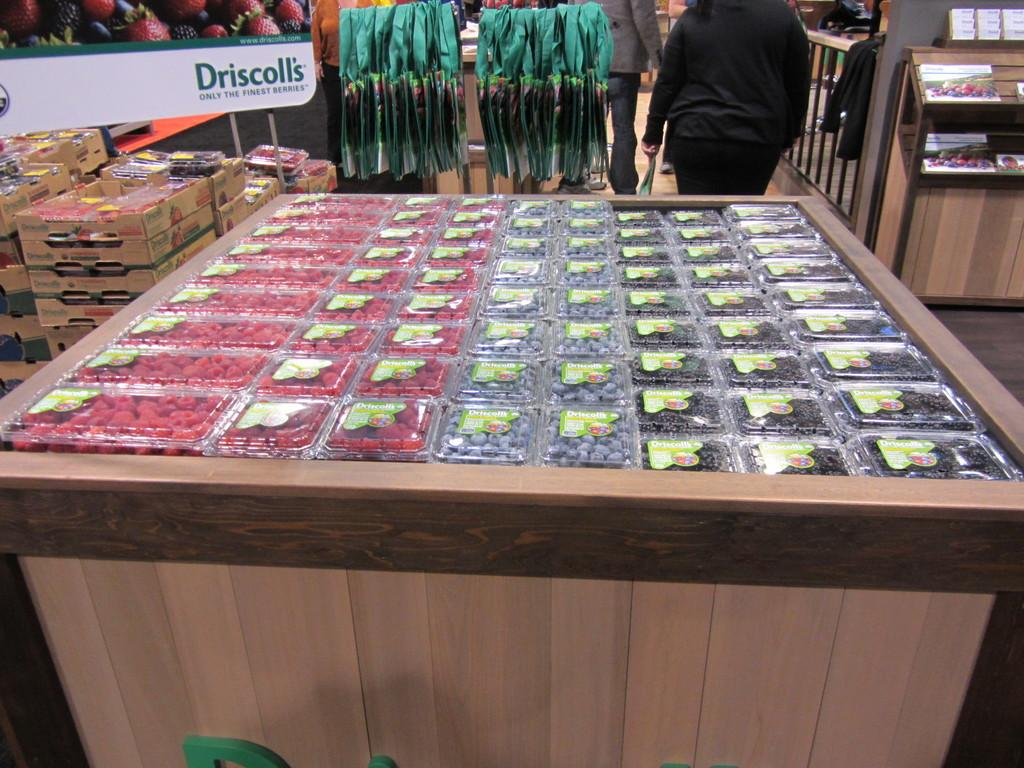Provide a one-sentence caption for the provided image. Driscoll's brand named berries in a super market display. 